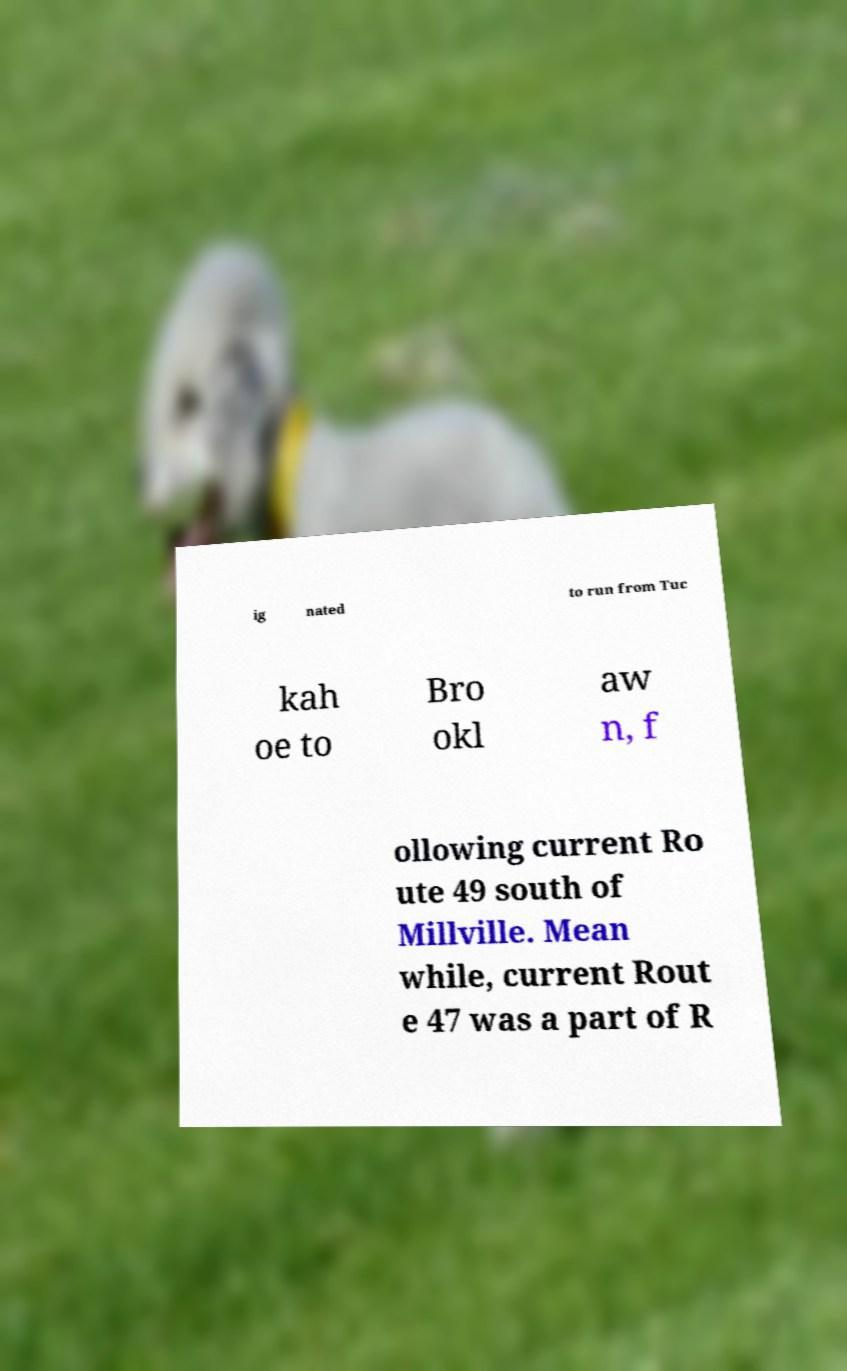Can you read and provide the text displayed in the image?This photo seems to have some interesting text. Can you extract and type it out for me? ig nated to run from Tuc kah oe to Bro okl aw n, f ollowing current Ro ute 49 south of Millville. Mean while, current Rout e 47 was a part of R 